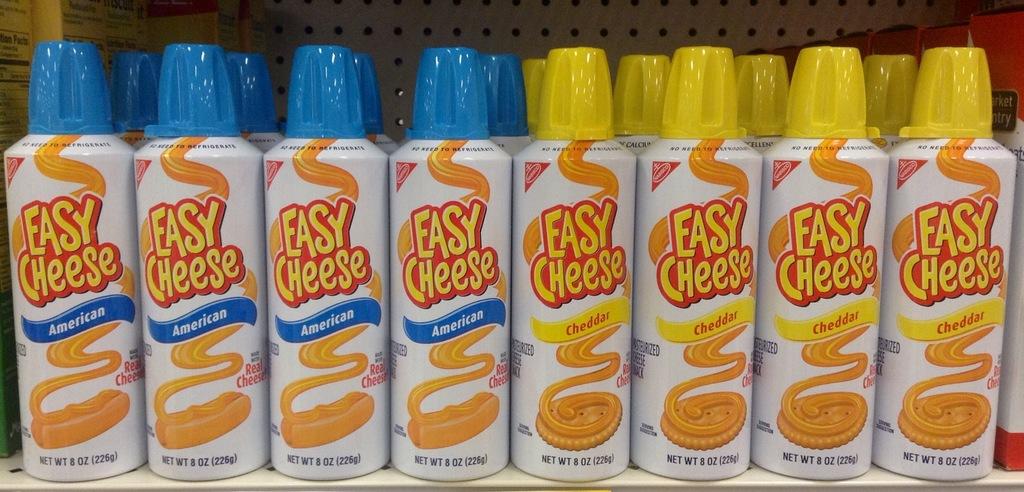What flavors are displayed here?
Offer a terse response. American and cheddar. What is the brand name?
Provide a short and direct response. Easy cheese. 